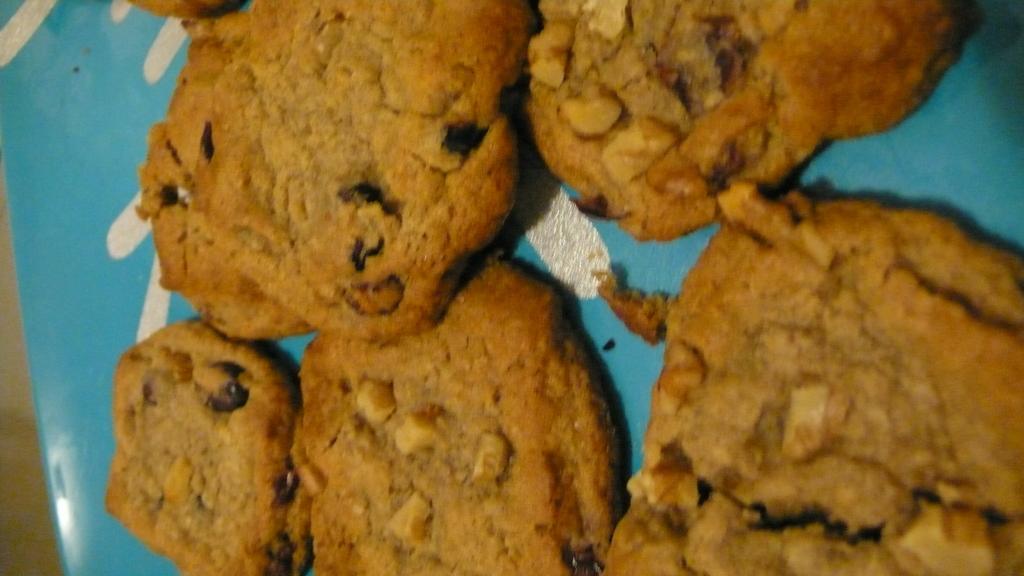Describe this image in one or two sentences. We can see cookies with plate. 